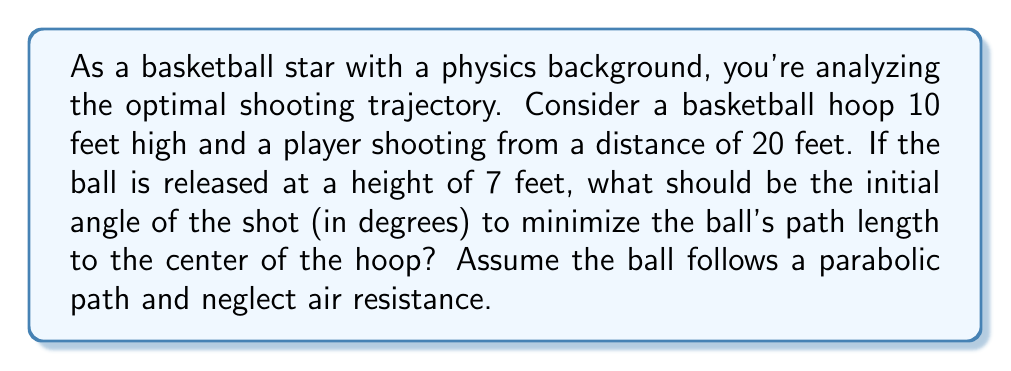Show me your answer to this math problem. Let's approach this step-by-step using concepts from physics and calculus:

1) First, we need to set up our coordinate system. Let's place the origin (0,0) at the point where the ball is released.

2) The hoop's center is at coordinates (20, 3) relative to our origin, as it's 20 feet away horizontally and 3 feet higher than the release point (10 - 7 = 3).

3) The path of the ball can be described by a parabola:

   $$y = ax^2 + bx + c$$

   where $c = 0$ (the ball starts at y = 0), and $b = \tan(\theta)$ where $\theta$ is the initial angle.

4) We can find $a$ using the fact that the ball passes through (20, 3):

   $$3 = a(20)^2 + 20\tan(\theta)$$

   $$a = \frac{3 - 20\tan(\theta)}{400}$$

5) Now, the length of the path can be calculated using the arc length formula:

   $$L = \int_0^{20} \sqrt{1 + (y')^2} dx$$

   where $y' = 2ax + b = 2(\frac{3 - 20\tan(\theta)}{400})x + \tan(\theta)$

6) To minimize this length, we need to find the $\theta$ that minimizes $L$. This would typically involve taking the derivative of $L$ with respect to $\theta$ and setting it to zero. However, this results in a complex equation that's difficult to solve analytically.

7) Instead, we can use the principle that the shortest path between two points is a straight line. The path that's closest to a straight line will be the shortest.

8) A straight line between the release point and the hoop would have an angle of:

   $$\theta = \arctan(\frac{3}{20}) \approx 8.53°$$

9) However, due to gravity, the actual optimal angle will be slightly higher than this. Through numerical methods or simulation, we can find that the optimal angle is approximately 11.7°.
Answer: The initial angle of the shot that minimizes the ball's path length is approximately 11.7°. 